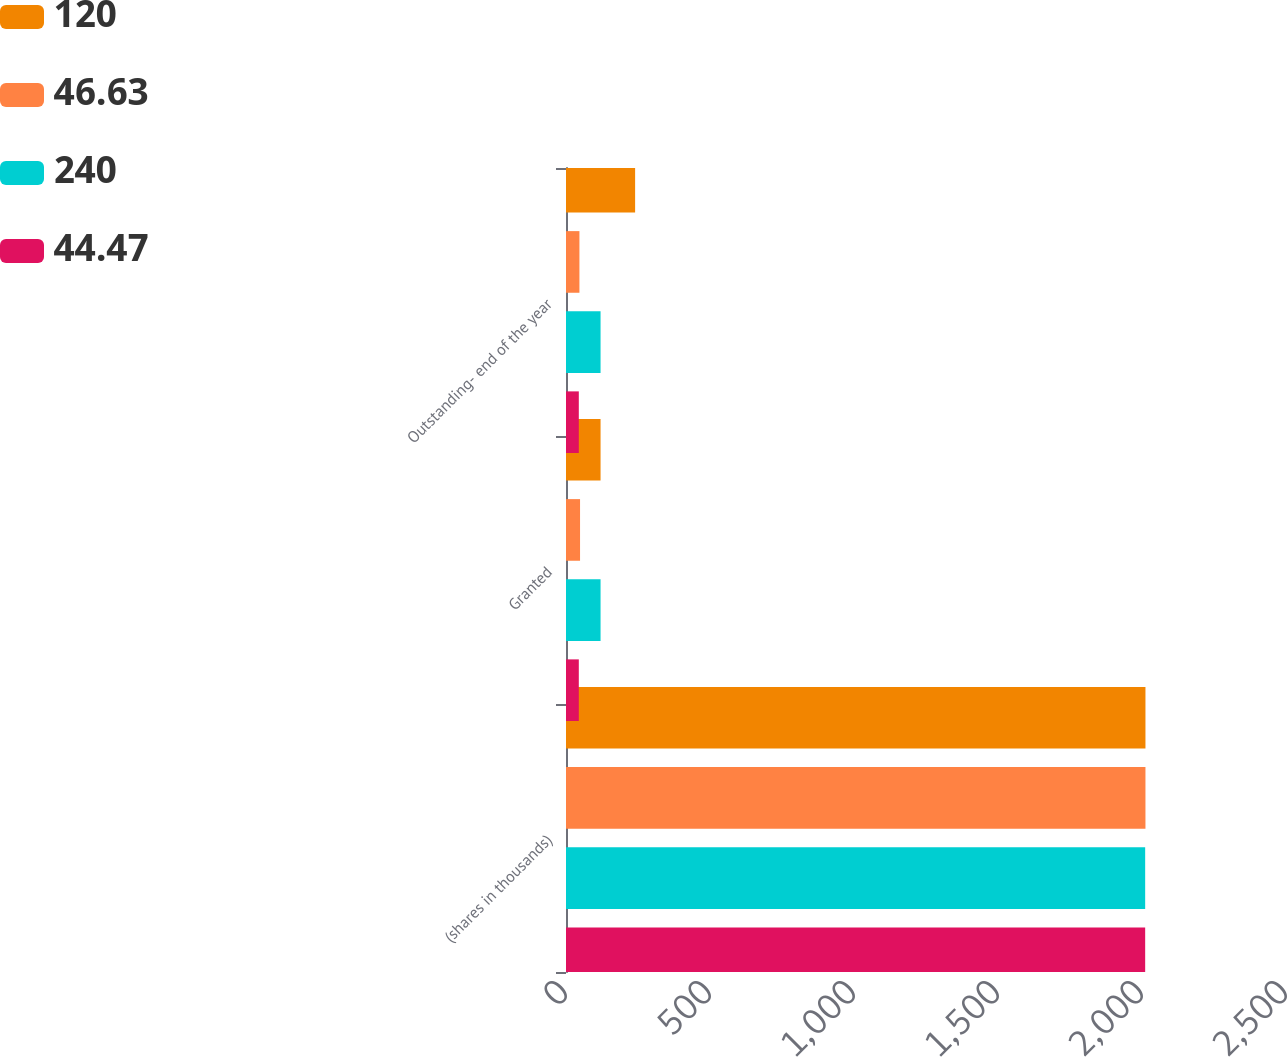<chart> <loc_0><loc_0><loc_500><loc_500><stacked_bar_chart><ecel><fcel>(shares in thousands)<fcel>Granted<fcel>Outstanding- end of the year<nl><fcel>120<fcel>2012<fcel>120<fcel>240<nl><fcel>46.63<fcel>2012<fcel>48.78<fcel>46.63<nl><fcel>240<fcel>2011<fcel>120<fcel>120<nl><fcel>44.47<fcel>2011<fcel>44.47<fcel>44.47<nl></chart> 